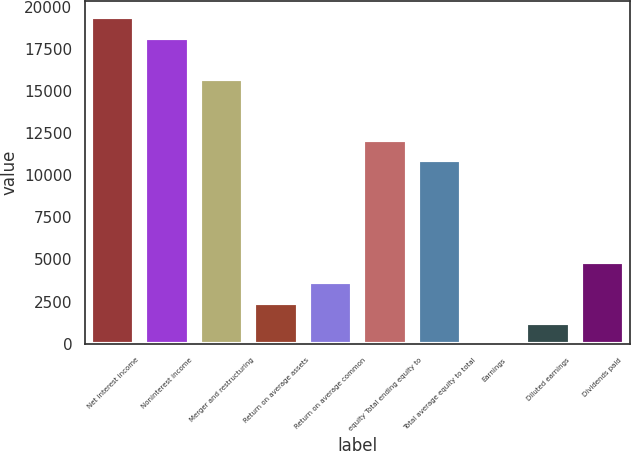<chart> <loc_0><loc_0><loc_500><loc_500><bar_chart><fcel>Net interest income<fcel>Noninterest income<fcel>Merger and restructuring<fcel>Return on average assets<fcel>Return on average common<fcel>equity Total ending equity to<fcel>Total average equity to total<fcel>Earnings<fcel>Diluted earnings<fcel>Dividends paid<nl><fcel>19369.5<fcel>18158.9<fcel>15737.8<fcel>2421.24<fcel>3631.84<fcel>12106<fcel>10895.4<fcel>0.05<fcel>1210.64<fcel>4842.44<nl></chart> 